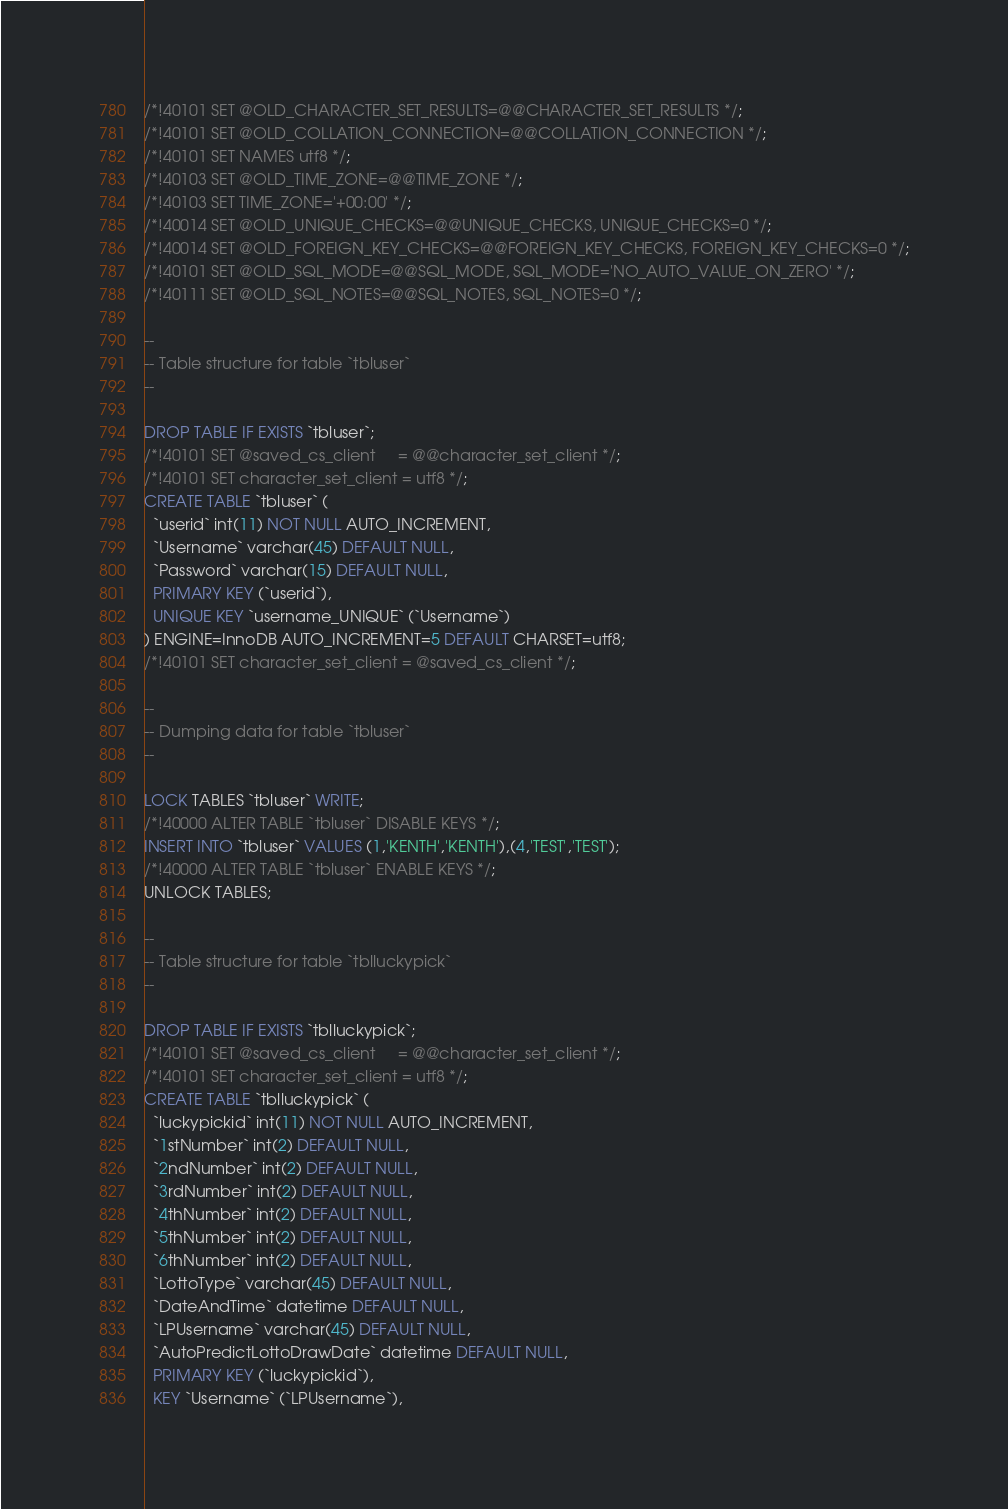Convert code to text. <code><loc_0><loc_0><loc_500><loc_500><_SQL_>/*!40101 SET @OLD_CHARACTER_SET_RESULTS=@@CHARACTER_SET_RESULTS */;
/*!40101 SET @OLD_COLLATION_CONNECTION=@@COLLATION_CONNECTION */;
/*!40101 SET NAMES utf8 */;
/*!40103 SET @OLD_TIME_ZONE=@@TIME_ZONE */;
/*!40103 SET TIME_ZONE='+00:00' */;
/*!40014 SET @OLD_UNIQUE_CHECKS=@@UNIQUE_CHECKS, UNIQUE_CHECKS=0 */;
/*!40014 SET @OLD_FOREIGN_KEY_CHECKS=@@FOREIGN_KEY_CHECKS, FOREIGN_KEY_CHECKS=0 */;
/*!40101 SET @OLD_SQL_MODE=@@SQL_MODE, SQL_MODE='NO_AUTO_VALUE_ON_ZERO' */;
/*!40111 SET @OLD_SQL_NOTES=@@SQL_NOTES, SQL_NOTES=0 */;

--
-- Table structure for table `tbluser`
--

DROP TABLE IF EXISTS `tbluser`;
/*!40101 SET @saved_cs_client     = @@character_set_client */;
/*!40101 SET character_set_client = utf8 */;
CREATE TABLE `tbluser` (
  `userid` int(11) NOT NULL AUTO_INCREMENT,
  `Username` varchar(45) DEFAULT NULL,
  `Password` varchar(15) DEFAULT NULL,
  PRIMARY KEY (`userid`),
  UNIQUE KEY `username_UNIQUE` (`Username`)
) ENGINE=InnoDB AUTO_INCREMENT=5 DEFAULT CHARSET=utf8;
/*!40101 SET character_set_client = @saved_cs_client */;

--
-- Dumping data for table `tbluser`
--

LOCK TABLES `tbluser` WRITE;
/*!40000 ALTER TABLE `tbluser` DISABLE KEYS */;
INSERT INTO `tbluser` VALUES (1,'KENTH','KENTH'),(4,'TEST','TEST');
/*!40000 ALTER TABLE `tbluser` ENABLE KEYS */;
UNLOCK TABLES;

--
-- Table structure for table `tblluckypick`
--

DROP TABLE IF EXISTS `tblluckypick`;
/*!40101 SET @saved_cs_client     = @@character_set_client */;
/*!40101 SET character_set_client = utf8 */;
CREATE TABLE `tblluckypick` (
  `luckypickid` int(11) NOT NULL AUTO_INCREMENT,
  `1stNumber` int(2) DEFAULT NULL,
  `2ndNumber` int(2) DEFAULT NULL,
  `3rdNumber` int(2) DEFAULT NULL,
  `4thNumber` int(2) DEFAULT NULL,
  `5thNumber` int(2) DEFAULT NULL,
  `6thNumber` int(2) DEFAULT NULL,
  `LottoType` varchar(45) DEFAULT NULL,
  `DateAndTime` datetime DEFAULT NULL,
  `LPUsername` varchar(45) DEFAULT NULL,
  `AutoPredictLottoDrawDate` datetime DEFAULT NULL,
  PRIMARY KEY (`luckypickid`),
  KEY `Username` (`LPUsername`),</code> 